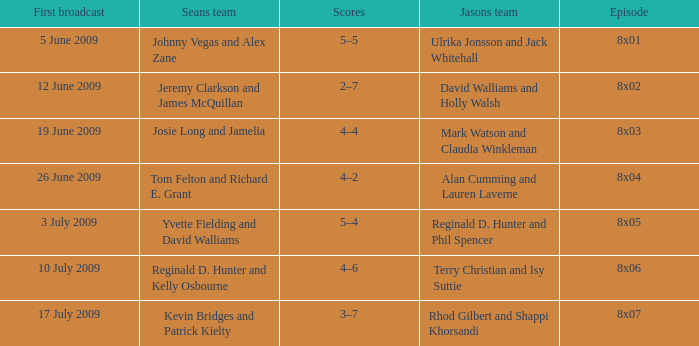What is the broadcast date where Jason's team is Rhod Gilbert and Shappi Khorsandi? 17 July 2009. 